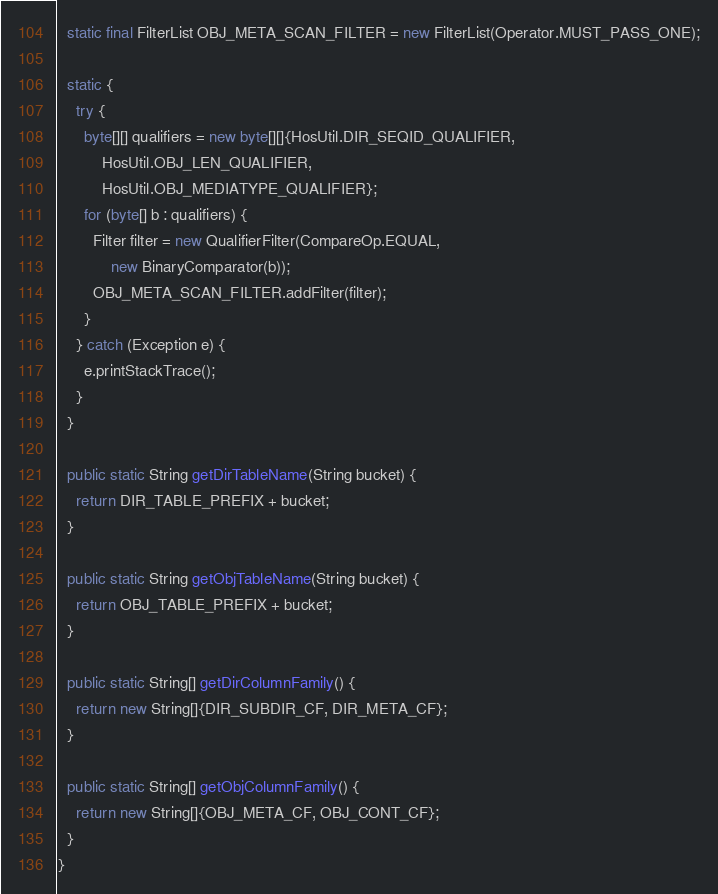<code> <loc_0><loc_0><loc_500><loc_500><_Java_>
  static final FilterList OBJ_META_SCAN_FILTER = new FilterList(Operator.MUST_PASS_ONE);

  static {
    try {
      byte[][] qualifiers = new byte[][]{HosUtil.DIR_SEQID_QUALIFIER,
          HosUtil.OBJ_LEN_QUALIFIER,
          HosUtil.OBJ_MEDIATYPE_QUALIFIER};
      for (byte[] b : qualifiers) {
        Filter filter = new QualifierFilter(CompareOp.EQUAL,
            new BinaryComparator(b));
        OBJ_META_SCAN_FILTER.addFilter(filter);
      }
    } catch (Exception e) {
      e.printStackTrace();
    }
  }

  public static String getDirTableName(String bucket) {
    return DIR_TABLE_PREFIX + bucket;
  }

  public static String getObjTableName(String bucket) {
    return OBJ_TABLE_PREFIX + bucket;
  }

  public static String[] getDirColumnFamily() {
    return new String[]{DIR_SUBDIR_CF, DIR_META_CF};
  }

  public static String[] getObjColumnFamily() {
    return new String[]{OBJ_META_CF, OBJ_CONT_CF};
  }
}
</code> 